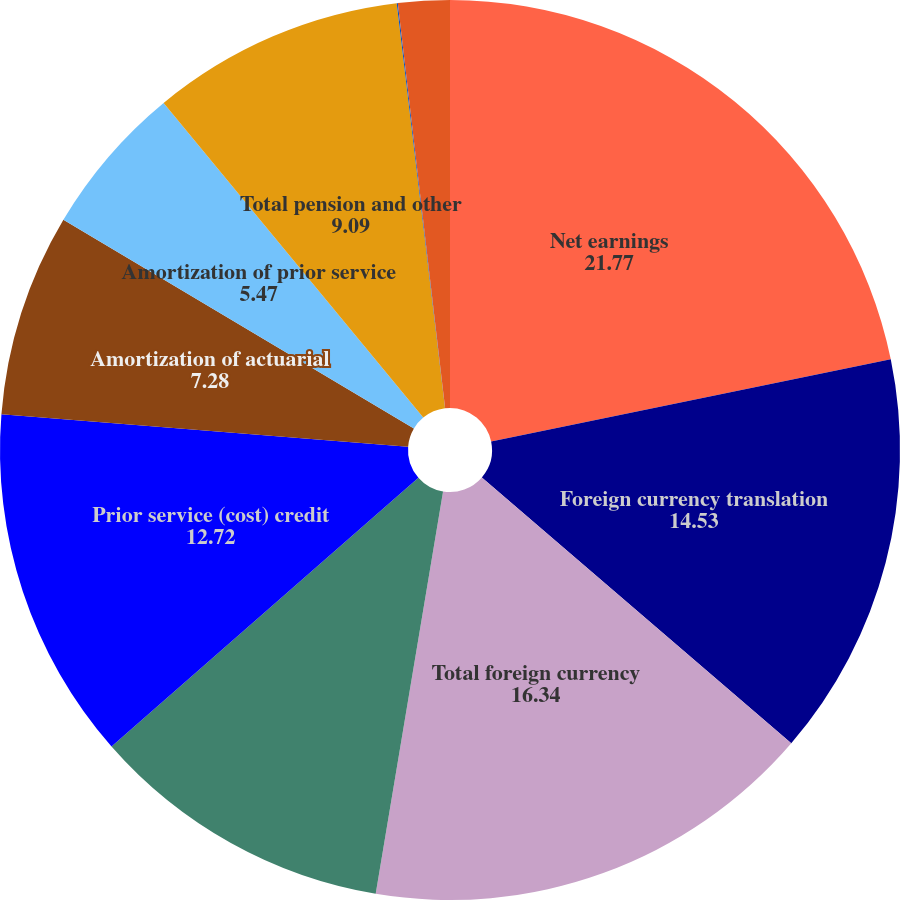Convert chart. <chart><loc_0><loc_0><loc_500><loc_500><pie_chart><fcel>Net earnings<fcel>Foreign currency translation<fcel>Total foreign currency<fcel>Actuarial (losses)gains<fcel>Prior service (cost) credit<fcel>Amortization of actuarial<fcel>Amortization of prior service<fcel>Total pension and other<fcel>Unrealized net gains (losses)<fcel>Net losses (gains)<nl><fcel>21.77%<fcel>14.53%<fcel>16.34%<fcel>10.91%<fcel>12.72%<fcel>7.28%<fcel>5.47%<fcel>9.09%<fcel>0.04%<fcel>1.85%<nl></chart> 